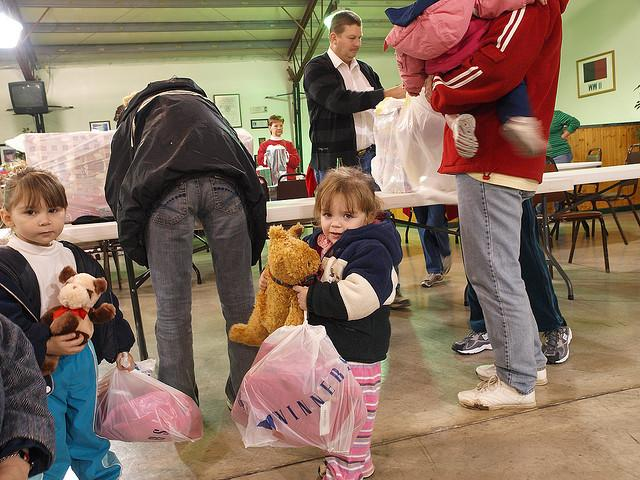What are the two girls in front doing?

Choices:
A) selling animals
B) waiting
C) standing line
D) stealing animals waiting 